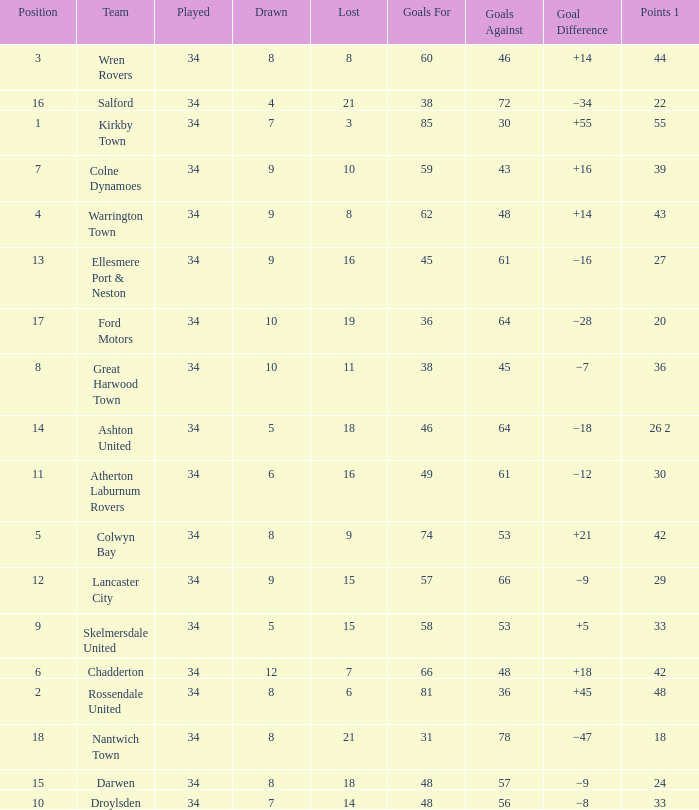What is the total number of goals for when the drawn is less than 7, less than 21 games have been lost, and there are 1 of 33 points? 1.0. 